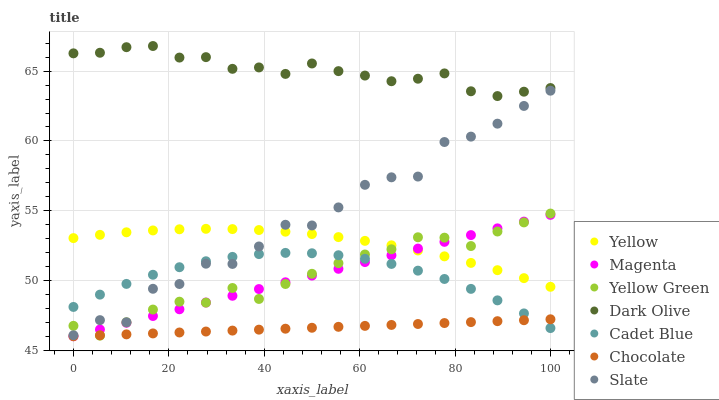Does Chocolate have the minimum area under the curve?
Answer yes or no. Yes. Does Dark Olive have the maximum area under the curve?
Answer yes or no. Yes. Does Yellow Green have the minimum area under the curve?
Answer yes or no. No. Does Yellow Green have the maximum area under the curve?
Answer yes or no. No. Is Chocolate the smoothest?
Answer yes or no. Yes. Is Slate the roughest?
Answer yes or no. Yes. Is Yellow Green the smoothest?
Answer yes or no. No. Is Yellow Green the roughest?
Answer yes or no. No. Does Chocolate have the lowest value?
Answer yes or no. Yes. Does Yellow Green have the lowest value?
Answer yes or no. No. Does Dark Olive have the highest value?
Answer yes or no. Yes. Does Yellow Green have the highest value?
Answer yes or no. No. Is Chocolate less than Slate?
Answer yes or no. Yes. Is Dark Olive greater than Cadet Blue?
Answer yes or no. Yes. Does Yellow Green intersect Cadet Blue?
Answer yes or no. Yes. Is Yellow Green less than Cadet Blue?
Answer yes or no. No. Is Yellow Green greater than Cadet Blue?
Answer yes or no. No. Does Chocolate intersect Slate?
Answer yes or no. No. 